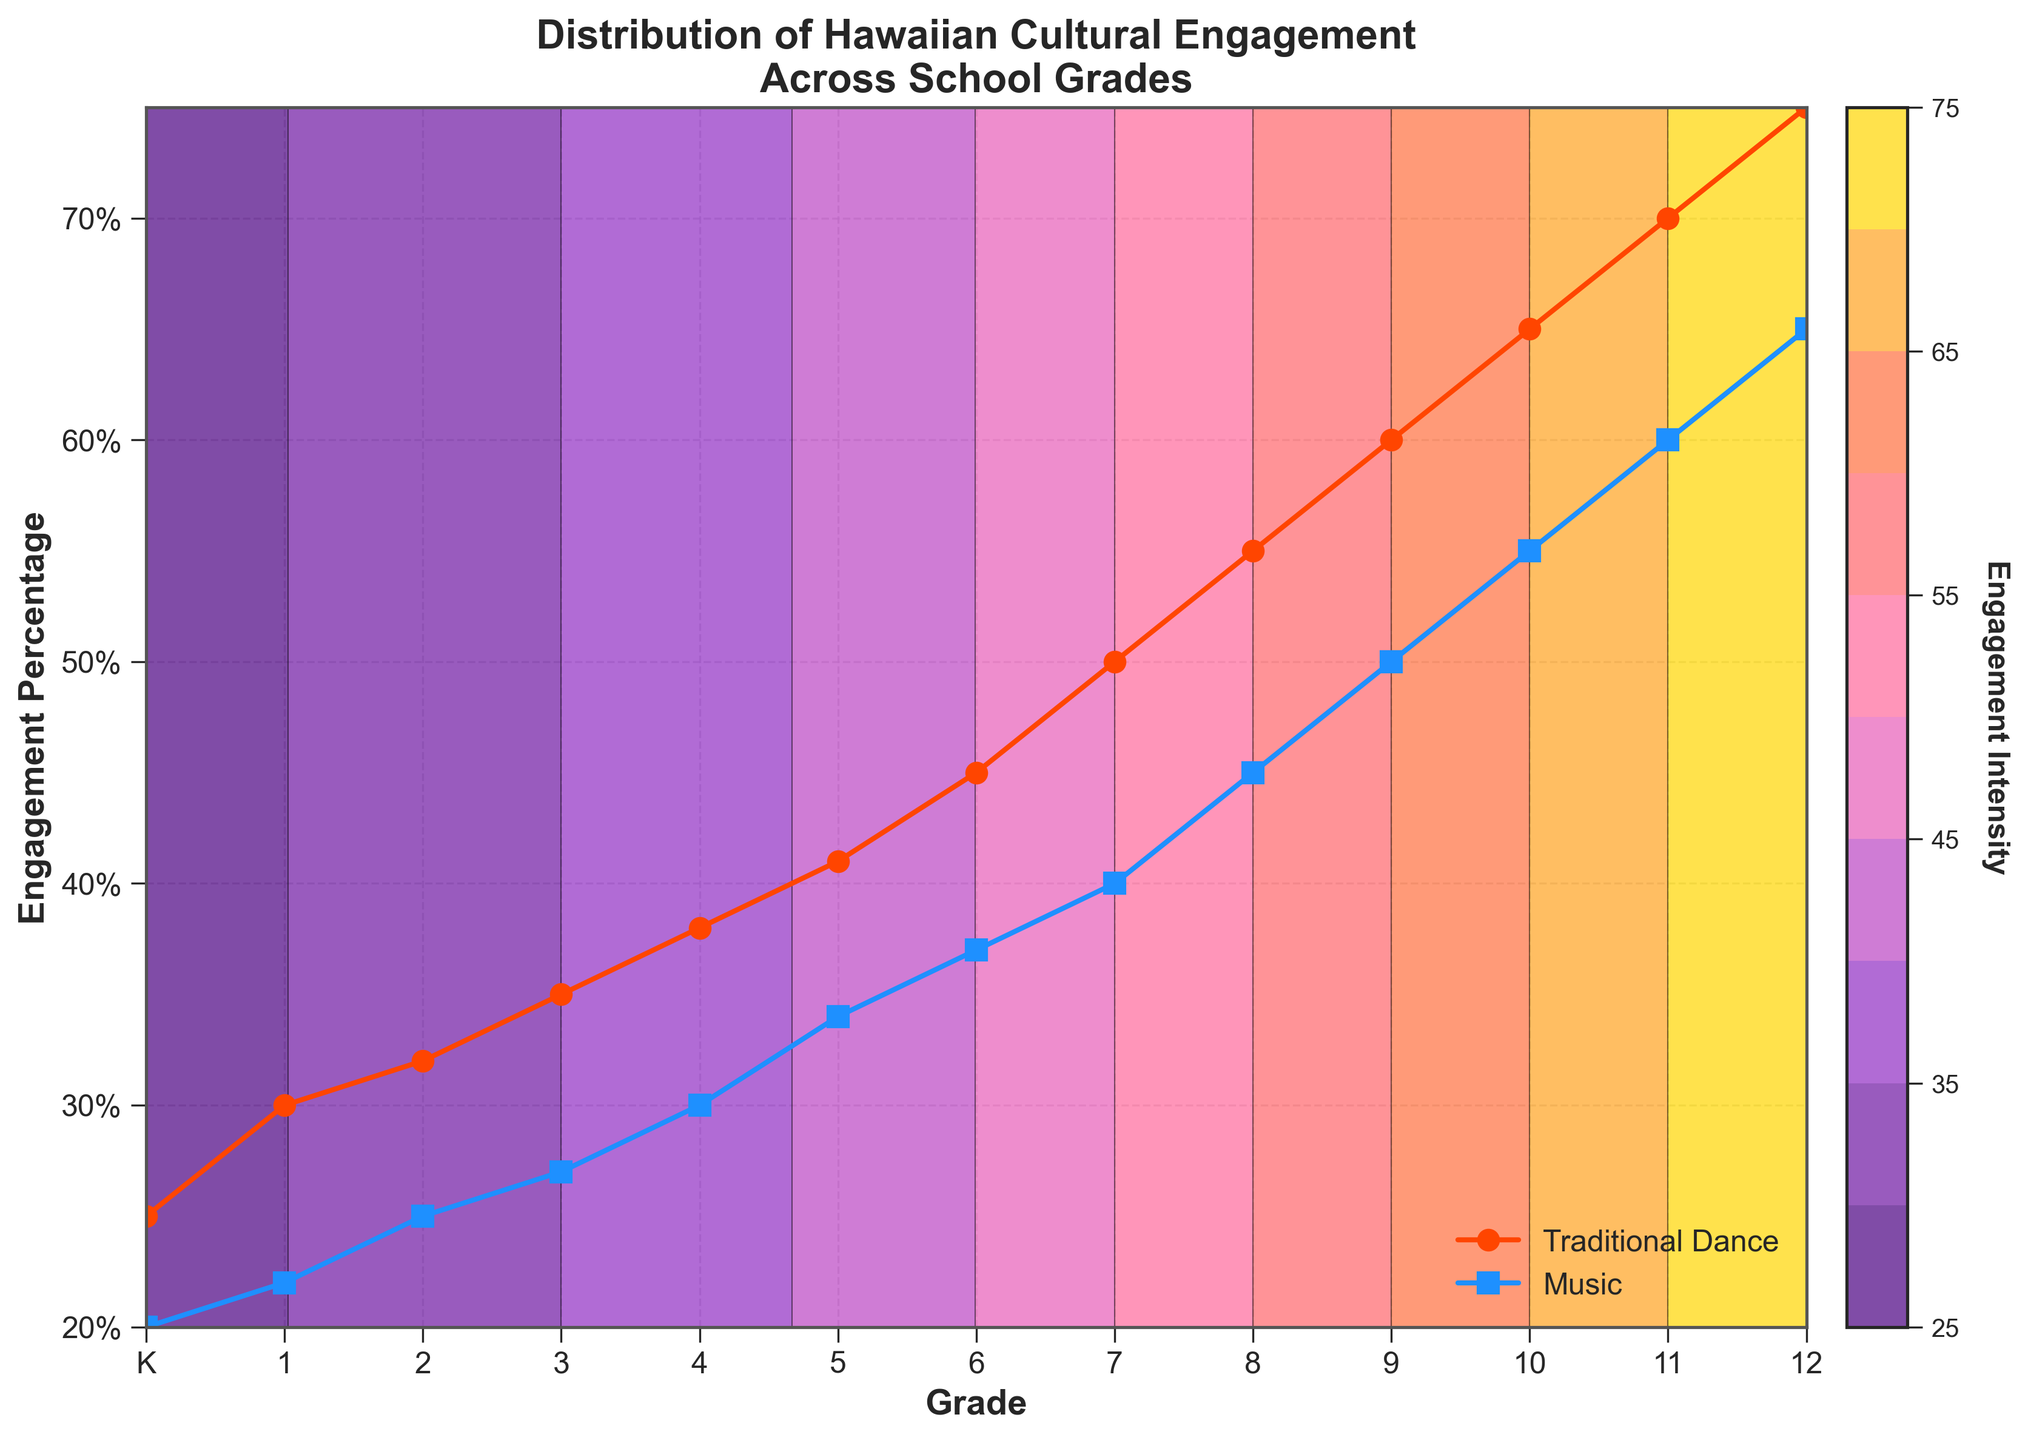What are the two engagement activities mentioned in the title? The title "Distribution of Hawaiian Cultural Engagement (Traditional Dance vs Music) Across Different School Grades" mentions Traditional Dance and Music as the two engagement activities.
Answer: Traditional Dance and Music What is the engagement percentage for Traditional Dance in Grade 6? By looking at the curve labeled "Traditional Dance," we find that the engagement percentage for Traditional Dance in Grade 6 is marked around 45%.
Answer: 45% At what grade does Music engagement reach 50%? By checking the curve labeled "Music," we see that the engagement percentage reaches 50% at Grade 9.
Answer: Grade 9 Which grade shows the highest engagement percentage for Traditional Dance? The "Traditional Dance" curve shows the highest engagement percentage at Grade 12, which reaches 75%.
Answer: Grade 12 How does the engagement in Music change from Grade 4 to Grade 5? The "Music" curve shows 30% at Grade 4 and 34% at Grade 5. The difference in engagement is 34% - 30% = 4%.
Answer: Increases by 4% Compare the engagement percentages of Traditional Dance and Music at Grade 7. At Grade 7, Traditional Dance engagement percentage is 50% while Music engagement percentage is 40%. Therefore, Traditional Dance has 10% higher engagement than Music.
Answer: Traditional Dance is 10% higher What is the average engagement percentage for Music across all grades? Sum the Music engagement percentages from Kindergarten to Grade 12 (20 + 22 + 25 + 27 + 30 + 34 + 37 + 40 + 45 + 50 + 55 + 60 + 65) = 510. Divide by the number of grades (13) to get the average 510 / 13 ≈ 39.23%.
Answer: 39.23% Describe the color gradient used in the contour plot and its purpose. The color gradient ranges from dark indigo to bright yellow, representing varying levels of engagement intensity. Darker colors indicate lower engagement, while brighter colors indicate higher engagement. This helps visually distinguish different engagement levels across grades.
Answer: Indigo to Yellow gradient for engagement intensity At what engagement percentage do the contours for Traditional Dance and Music cross each other, if at all? The contours for Traditional Dance and Music do not cross each other in the plot, as Traditional Dance always has higher engagement percentages across all grades compared to Music.
Answer: They do not cross What is the range of engagement percentages displayed on the y-axis? The y-axis ranges from 20% to 75% as indicated by the tick labels.
Answer: 20% to 75% 